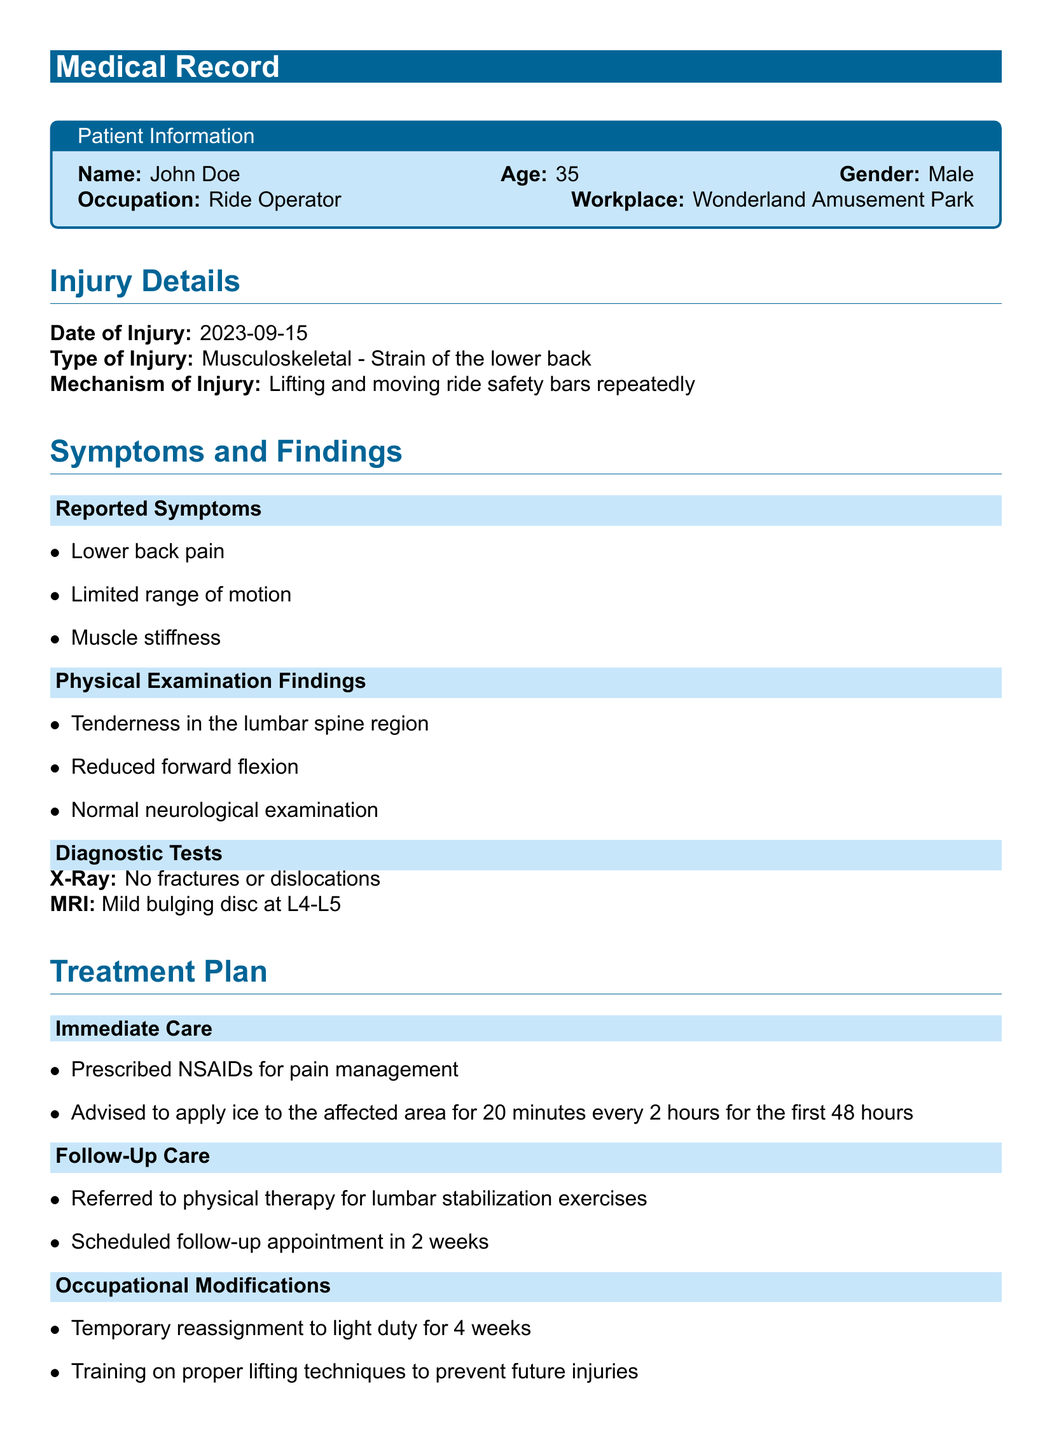What is the patient's name? The patient's name is listed in the Patient Information section of the document.
Answer: John Doe What type of injury did the patient sustain? The type of injury is mentioned under the Injury Details section.
Answer: Musculoskeletal - Strain of the lower back When did the injury occur? The date of the injury is specified in the Injury Details section.
Answer: 2023-09-15 What diagnostic test showed a mild bulging disc? The diagnostic tests are detailed in the Symptoms and Findings section.
Answer: MRI What is one immediate care recommendation for the patient? The immediate care recommendations are found in the Treatment Plan section.
Answer: Prescribed NSAIDs for pain management What occupational modification was made for the patient? The occupational modifications are listed in the Treatment Plan section.
Answer: Temporary reassignment to light duty for 4 weeks What is one engineering control suggested to prevent future injuries? The prevention strategies are outlined in the last section of the document.
Answer: Installation of hydraulic systems to assist with lifting ride safety bars How long is the follow-up appointment scheduled after the initial visit? The follow-up care timeline is provided in the Treatment Plan section.
Answer: In 2 weeks What kind of exercises was the patient referred for? The type of therapy referred is mentioned in the Follow-Up Care subsection.
Answer: Lumbar stabilization exercises What kind of training is recommended for amusement park workers? The recommended training is stated in the Prevention Strategies section.
Answer: Regular workshops on ergonomics and safe work practices 